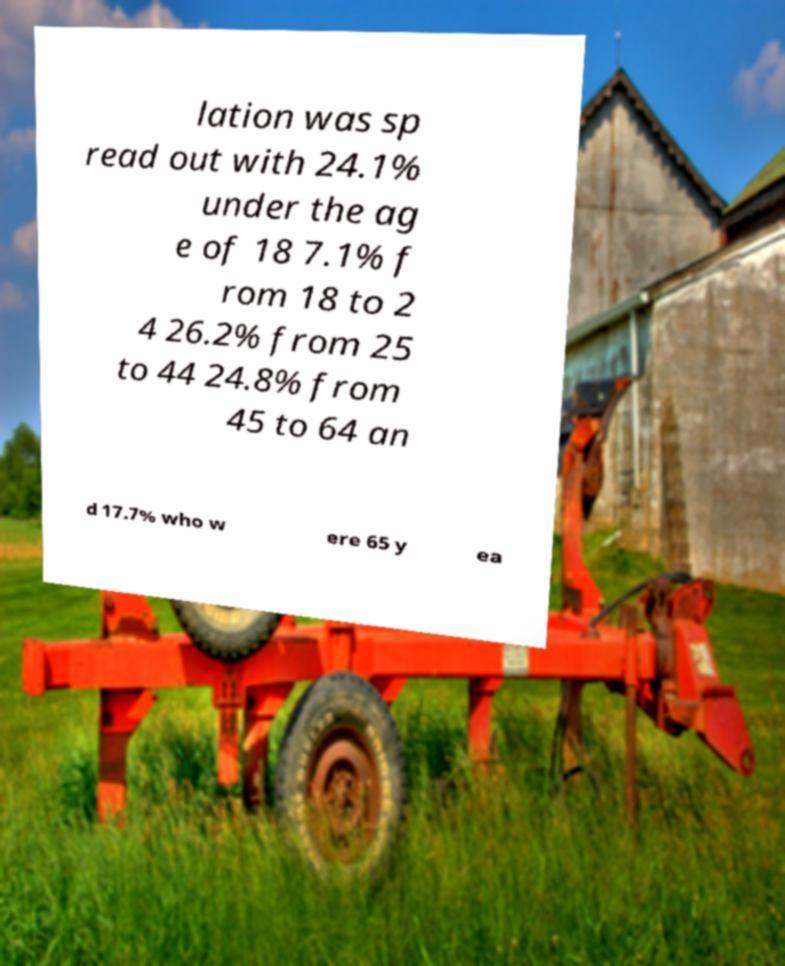There's text embedded in this image that I need extracted. Can you transcribe it verbatim? lation was sp read out with 24.1% under the ag e of 18 7.1% f rom 18 to 2 4 26.2% from 25 to 44 24.8% from 45 to 64 an d 17.7% who w ere 65 y ea 